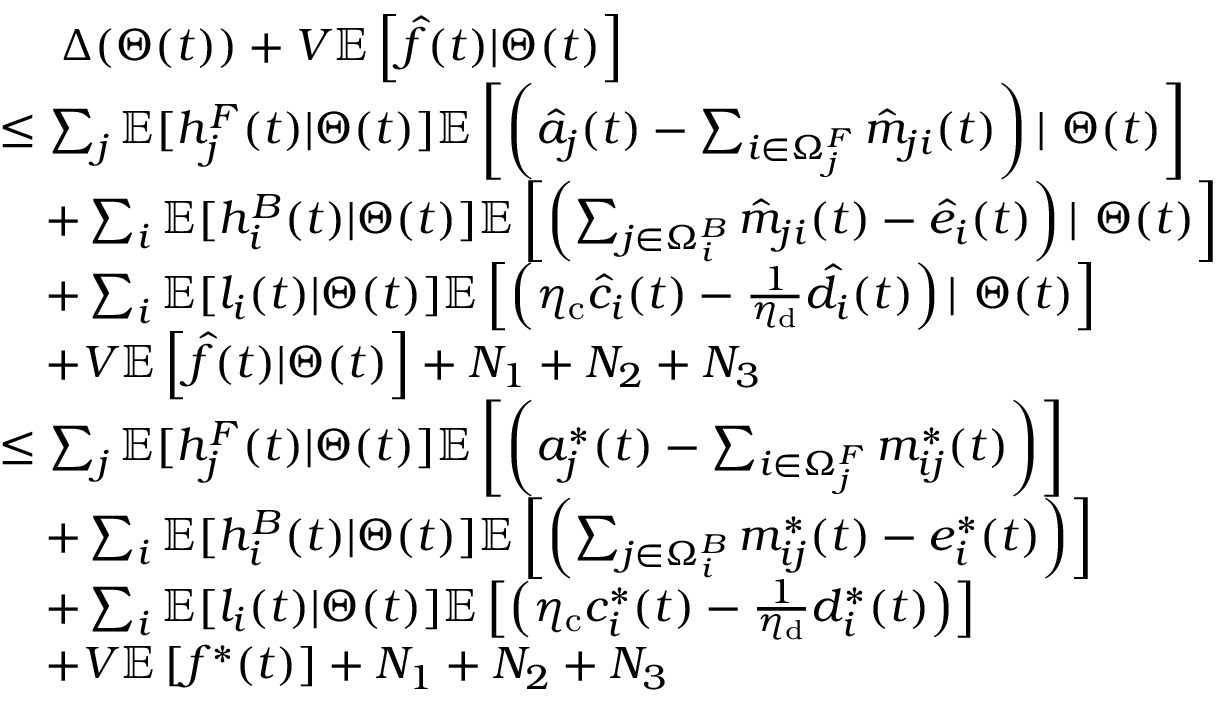<formula> <loc_0><loc_0><loc_500><loc_500>\begin{array} { r l } & { \quad \Delta ( \Theta ( t ) ) + V \mathbb { E } \left [ \hat { f } ( t ) | \Theta ( t ) \right ] } \\ & { \leq \sum _ { j } \mathbb { E } [ h _ { j } ^ { F } ( t ) | \Theta ( t ) ] \mathbb { E } \left [ \left ( \hat { a } _ { j } ( t ) - \sum _ { i \in \Omega _ { j } ^ { F } } \hat { m } _ { j i } ( t ) \right ) | \Theta ( t ) \right ] } \\ & { \quad + \sum _ { i } \mathbb { E } [ h _ { i } ^ { B } ( t ) | \Theta ( t ) ] \mathbb { E } \left [ \left ( \sum _ { j \in \Omega _ { i } ^ { B } } \hat { m } _ { j i } ( t ) - \hat { e } _ { i } ( t ) \right ) | \Theta ( t ) \right ] } \\ & { \quad + \sum _ { i } \mathbb { E } [ l _ { i } ( t ) | \Theta ( t ) ] \mathbb { E } \left [ \left ( \eta _ { c } \hat { c } _ { i } ( t ) - \frac { 1 } { \eta _ { d } } \hat { d } _ { i } ( t ) \right ) | \Theta ( t ) \right ] } \\ & { \quad + V \mathbb { E } \left [ \hat { f } ( t ) | \Theta ( t ) \right ] + N _ { 1 } + N _ { 2 } + N _ { 3 } } \\ & { \leq \sum _ { j } \mathbb { E } [ h _ { j } ^ { F } ( t ) | \Theta ( t ) ] \mathbb { E } \left [ \left ( a _ { j } ^ { * } ( t ) - \sum _ { i \in \Omega _ { j } ^ { F } } m _ { i j } ^ { * } ( t ) \right ) \right ] } \\ & { \quad + \sum _ { i } \mathbb { E } [ h _ { i } ^ { B } ( t ) | \Theta ( t ) ] \mathbb { E } \left [ \left ( \sum _ { j \in \Omega _ { i } ^ { B } } m _ { i j } ^ { * } ( t ) - e _ { i } ^ { * } ( t ) \right ) \right ] } \\ & { \quad + \sum _ { i } \mathbb { E } [ l _ { i } ( t ) | \Theta ( t ) ] \mathbb { E } \left [ \left ( \eta _ { c } c _ { i } ^ { * } ( t ) - \frac { 1 } { \eta _ { d } } d _ { i } ^ { * } ( t ) \right ) \right ] } \\ & { \quad + V \mathbb { E } \left [ f ^ { * } ( t ) \right ] + N _ { 1 } + N _ { 2 } + N _ { 3 } } \end{array}</formula> 